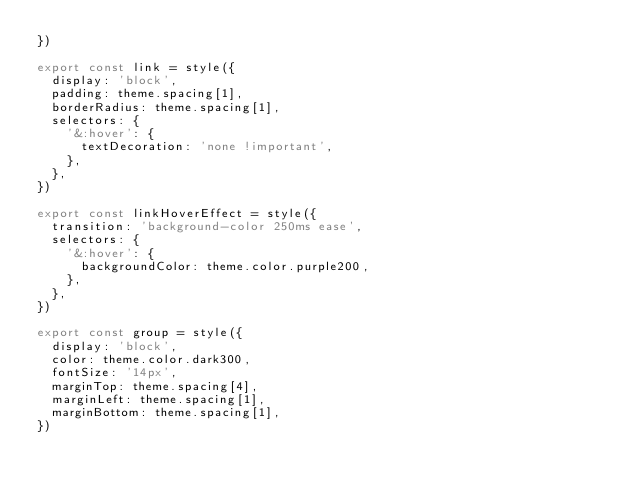Convert code to text. <code><loc_0><loc_0><loc_500><loc_500><_TypeScript_>})

export const link = style({
  display: 'block',
  padding: theme.spacing[1],
  borderRadius: theme.spacing[1],
  selectors: {
    '&:hover': {
      textDecoration: 'none !important',
    },
  },
})

export const linkHoverEffect = style({
  transition: 'background-color 250ms ease',
  selectors: {
    '&:hover': {
      backgroundColor: theme.color.purple200,
    },
  },
})

export const group = style({
  display: 'block',
  color: theme.color.dark300,
  fontSize: '14px',
  marginTop: theme.spacing[4],
  marginLeft: theme.spacing[1],
  marginBottom: theme.spacing[1],
})
</code> 